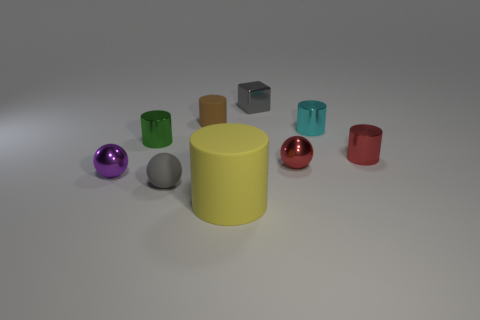What is the material of the object that is the same color as the small matte ball?
Offer a terse response. Metal. There is a matte object on the right side of the brown cylinder; is its size the same as the matte ball?
Provide a short and direct response. No. Is there any other thing that is the same size as the yellow thing?
Make the answer very short. No. What number of other things are there of the same material as the tiny red cylinder
Your response must be concise. 5. What is the shape of the gray thing that is in front of the metallic sphere to the left of the rubber object that is in front of the rubber sphere?
Provide a succinct answer. Sphere. Are there fewer tiny gray metal things to the left of the tiny gray matte thing than tiny cyan shiny cylinders that are in front of the red metallic sphere?
Give a very brief answer. No. Is there a ball that has the same color as the big rubber thing?
Give a very brief answer. No. Does the green cylinder have the same material as the gray thing that is behind the tiny brown thing?
Make the answer very short. Yes. Are there any cyan things that are right of the matte object behind the purple shiny sphere?
Make the answer very short. Yes. There is a small cylinder that is on the left side of the metal block and right of the small gray matte ball; what color is it?
Your answer should be very brief. Brown. 